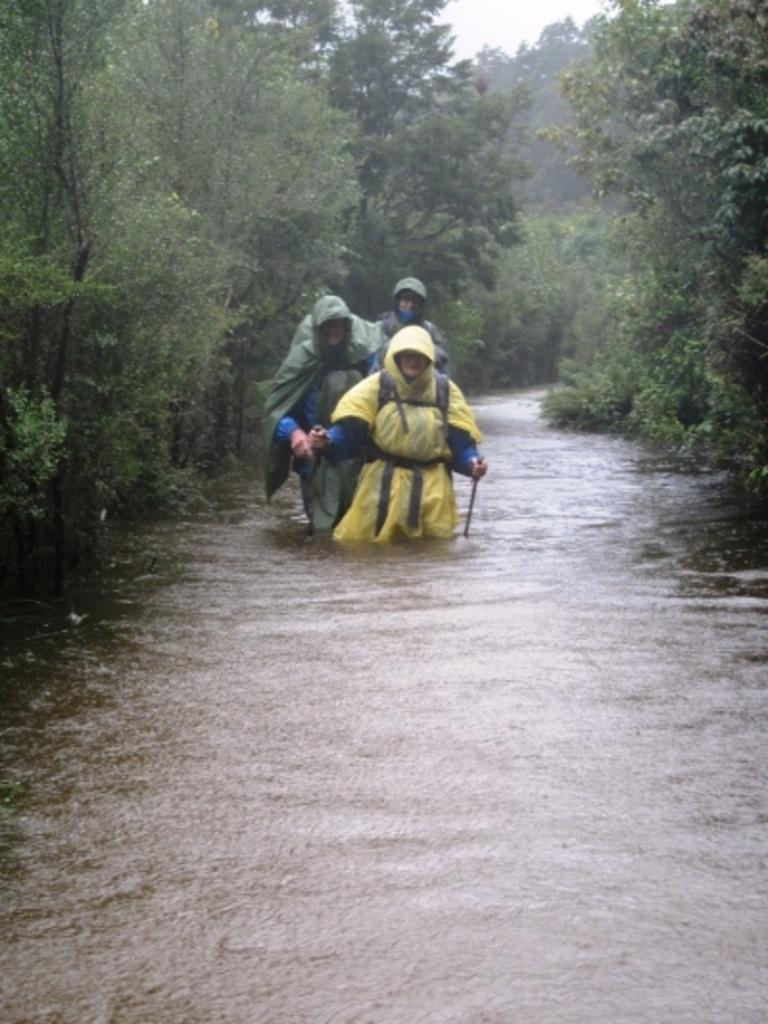Who or what can be seen in the image? There are people in the image. What is the primary element visible in the image? There is water visible in the image. What type of vegetation is present in the image? There are trees in the image. What can be seen in the background of the image? The sky is visible in the background of the image. What type of paste is being used by the people in the image? There is no paste visible in the image, and the people are not using any paste. 